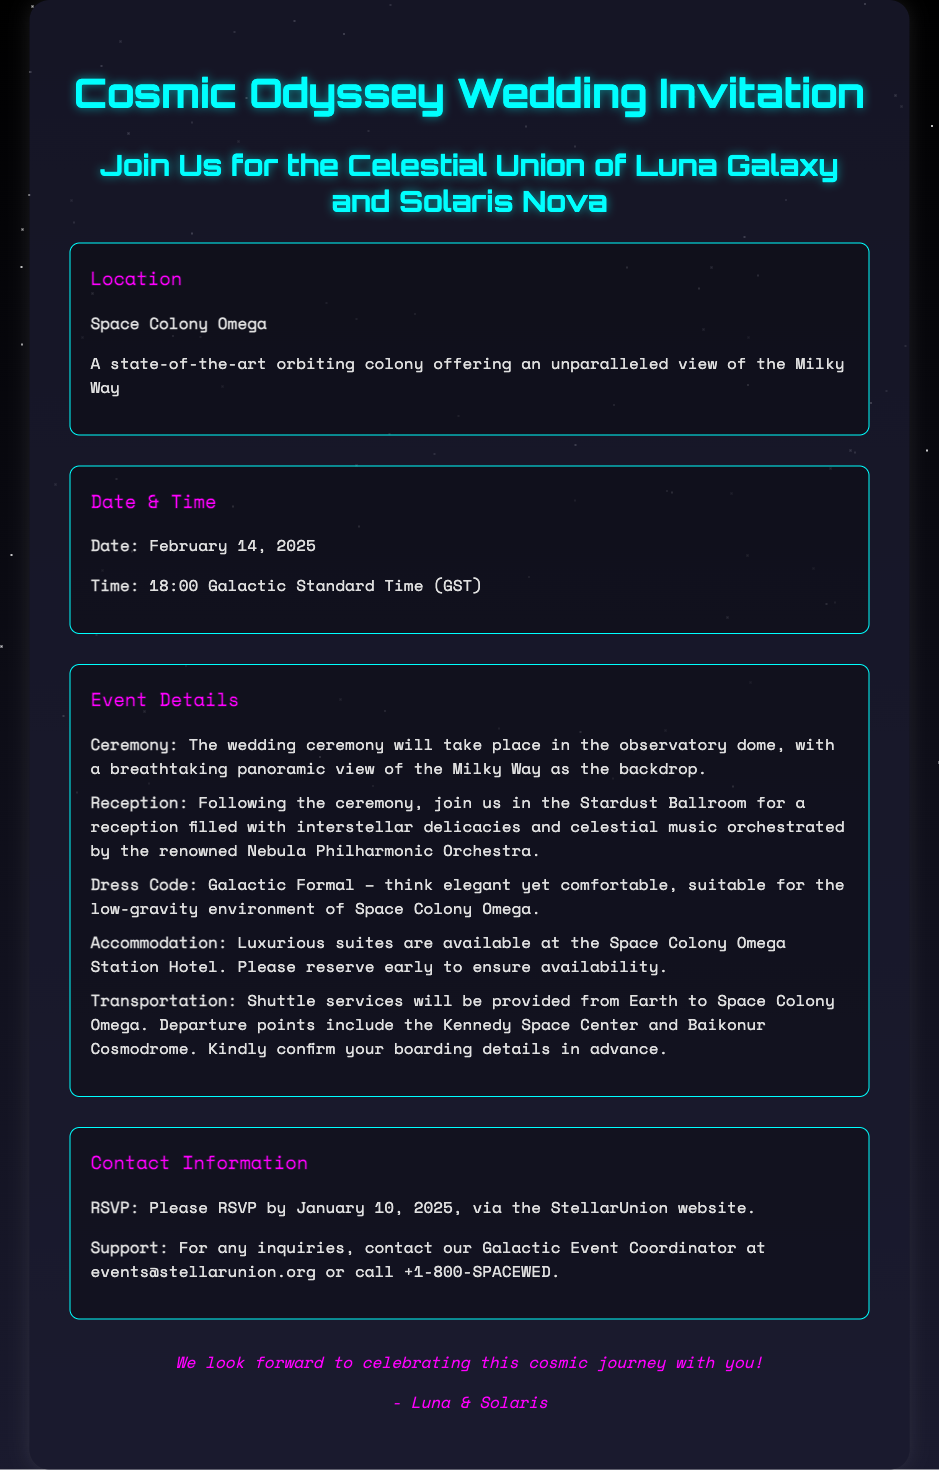What is the date of the wedding? The date of the wedding is specified in the document as February 14, 2025.
Answer: February 14, 2025 What is the location of the wedding? The location of the wedding is given as Space Colony Omega.
Answer: Space Colony Omega What time will the wedding ceremony begin? The time for the ceremony is mentioned as 18:00 Galactic Standard Time (GST).
Answer: 18:00 Galactic Standard Time (GST) What is the dress code for the event? The dress code is described as Galactic Formal in the details section of the document.
Answer: Galactic Formal Who are the couple getting married? The couple's names are given as Luna Galaxy and Solaris Nova in the invitation.
Answer: Luna Galaxy and Solaris Nova What type of music will be played at the reception? The reception music will be provided by the renowned Nebula Philharmonic Orchestra, as specified in the document.
Answer: Nebula Philharmonic Orchestra When is the RSVP deadline? The RSVP deadline is provided as January 10, 2025 in the invitation.
Answer: January 10, 2025 What should guests confirm in advance? Guests are instructed to confirm their boarding details in advance as part of the transportation information.
Answer: Boarding details Where will the accommodation be provided? Accommodation is mentioned to be available at the Space Colony Omega Station Hotel.
Answer: Space Colony Omega Station Hotel 